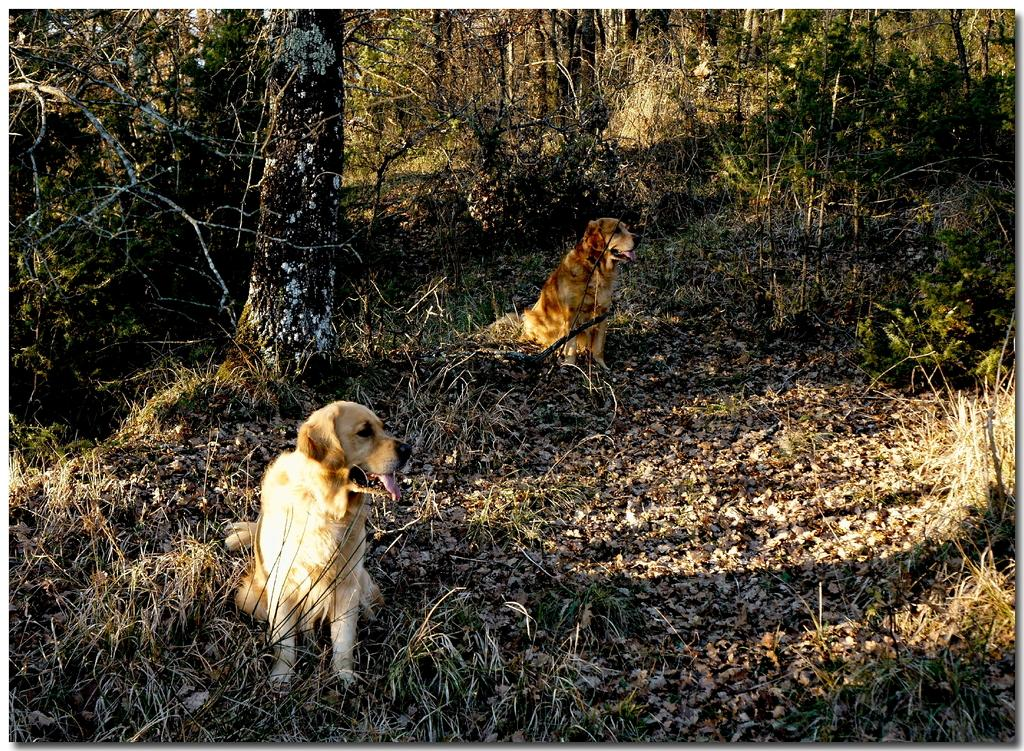What animals are sitting on the ground in the image? There are dogs sitting on the ground in the image. What type of vegetation can be seen on the ground in the image? Shredded leaves are visible in the image. What type of vegetation is present in the image besides the shredded leaves? There are plants in the image. What can be seen in the background of the image? Trees and the sky are visible in the image. What type of crack is visible in the image? There is no crack visible in the image. Can you see any spies in the image? There are no spies present in the image. 